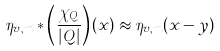Convert formula to latex. <formula><loc_0><loc_0><loc_500><loc_500>\eta _ { v , m } \ast \left ( \frac { \chi _ { Q } } { | Q | } \right ) ( x ) \approx \eta _ { v , m } ( x - y )</formula> 